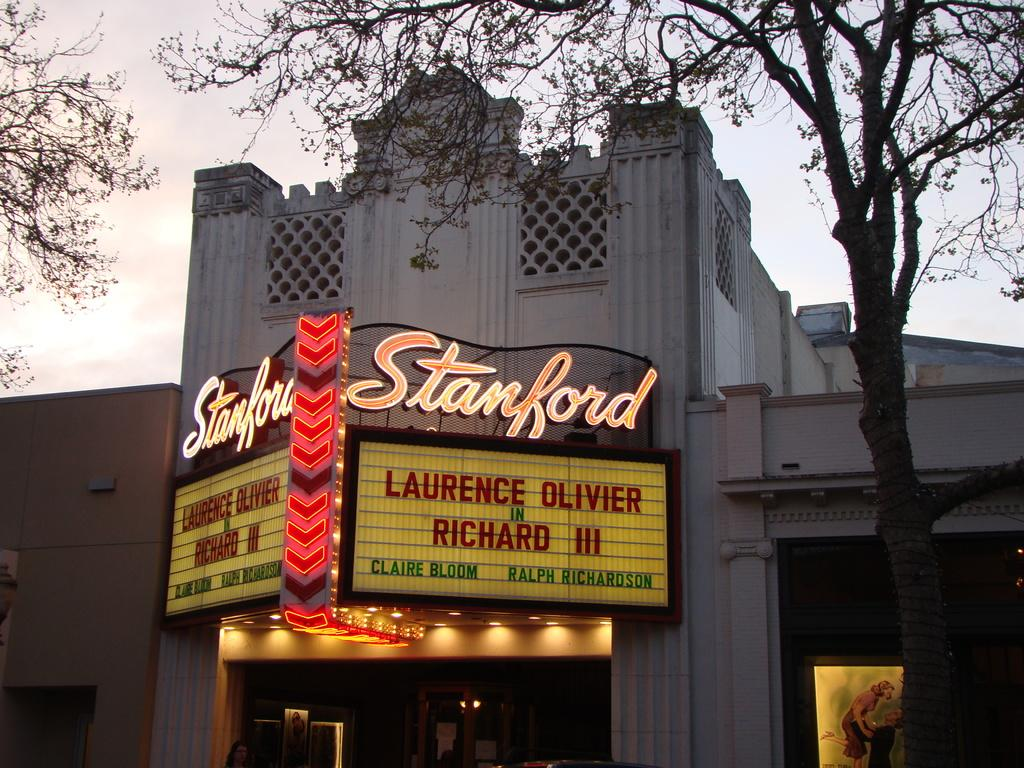What type of structures can be seen in the image? There are buildings in the image. What else is present in the image besides the buildings? There are boards, a person, trees, some objects, and the sky is visible in the background. What type of flower is being used as a prop by the person in the image? There is no flower present in the image; the person is not holding or interacting with any flower. 